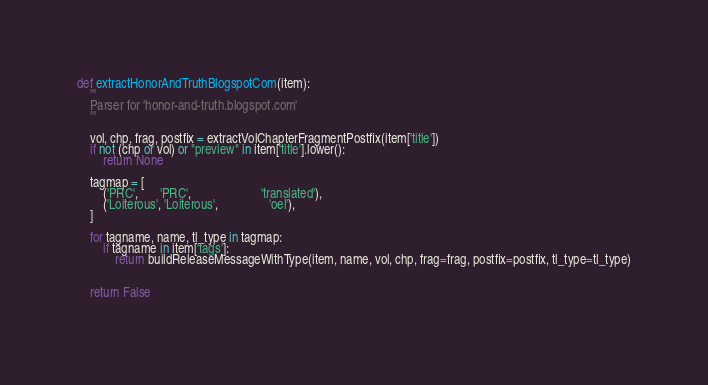Convert code to text. <code><loc_0><loc_0><loc_500><loc_500><_Python_>
def extractHonorAndTruthBlogspotCom(item):
	'''
	Parser for 'honor-and-truth.blogspot.com'
	'''

	vol, chp, frag, postfix = extractVolChapterFragmentPostfix(item['title'])
	if not (chp or vol) or "preview" in item['title'].lower():
		return None

	tagmap = [
		('PRC',       'PRC',                      'translated'),
		('Loiterous', 'Loiterous',                'oel'),
	]

	for tagname, name, tl_type in tagmap:
		if tagname in item['tags']:
			return buildReleaseMessageWithType(item, name, vol, chp, frag=frag, postfix=postfix, tl_type=tl_type)


	return False
	</code> 